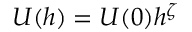Convert formula to latex. <formula><loc_0><loc_0><loc_500><loc_500>\ U ( h ) = U ( 0 ) h ^ { \zeta }</formula> 